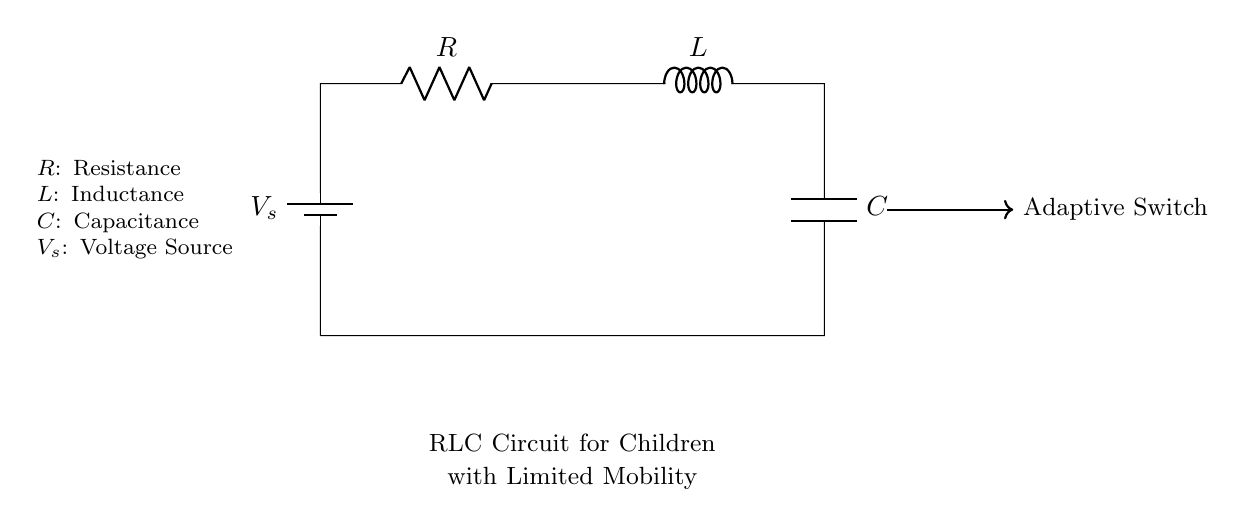What is the symbol for the battery in this circuit? The battery is represented by a symbol with two lines, one longer (positive terminal) and one shorter (negative terminal). This indicates the source of electrical power in the circuit.
Answer: Battery What are the components of this RLC circuit? The circuit consists of three main components: a resistor, an inductor, and a capacitor, connected in series. These components are essential for controlling the flow of current and storing energy.
Answer: Resistor, Inductor, Capacitor What is the role of the adaptive switch in this circuit? The adaptive switch allows for control and activation of the circuit, enabling children with limited mobility to operate devices or tools. It is an integral part of making the circuit functional and user-friendly.
Answer: Control and activation What is the function of the resistor in this circuit? The resistor controls the amount of current flowing through the circuit by providing resistance, which can prevent overload situations and ensure safe operation of the device.
Answer: Current control What happens when we increase the capacitance in this circuit? Increasing the capacitance will lead to an increase in the energy storage capability of the circuit. This can affect the charge time and the overall response time of the circuit, potentially allowing for longer operation or different timing behaviors.
Answer: Longer operation How does the inductor impact the circuit's performance? The inductor stores energy in a magnetic field when current passes through it and affects the circuit's impedance. This can lead to a delayed response in current changes, impacting the timing and stability of the circuit’s performance.
Answer: Delayed response 